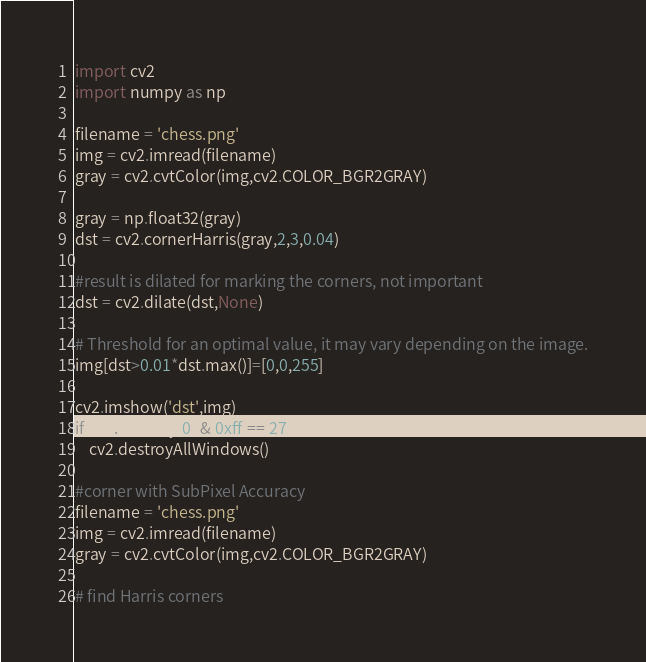<code> <loc_0><loc_0><loc_500><loc_500><_Python_>import cv2
import numpy as np

filename = 'chess.png'
img = cv2.imread(filename)
gray = cv2.cvtColor(img,cv2.COLOR_BGR2GRAY)

gray = np.float32(gray)
dst = cv2.cornerHarris(gray,2,3,0.04)

#result is dilated for marking the corners, not important
dst = cv2.dilate(dst,None)

# Threshold for an optimal value, it may vary depending on the image.
img[dst>0.01*dst.max()]=[0,0,255]

cv2.imshow('dst',img)
if cv2.waitKey(0) & 0xff == 27:
    cv2.destroyAllWindows()

#corner with SubPixel Accuracy
filename = 'chess.png'
img = cv2.imread(filename)
gray = cv2.cvtColor(img,cv2.COLOR_BGR2GRAY)

# find Harris corners</code> 